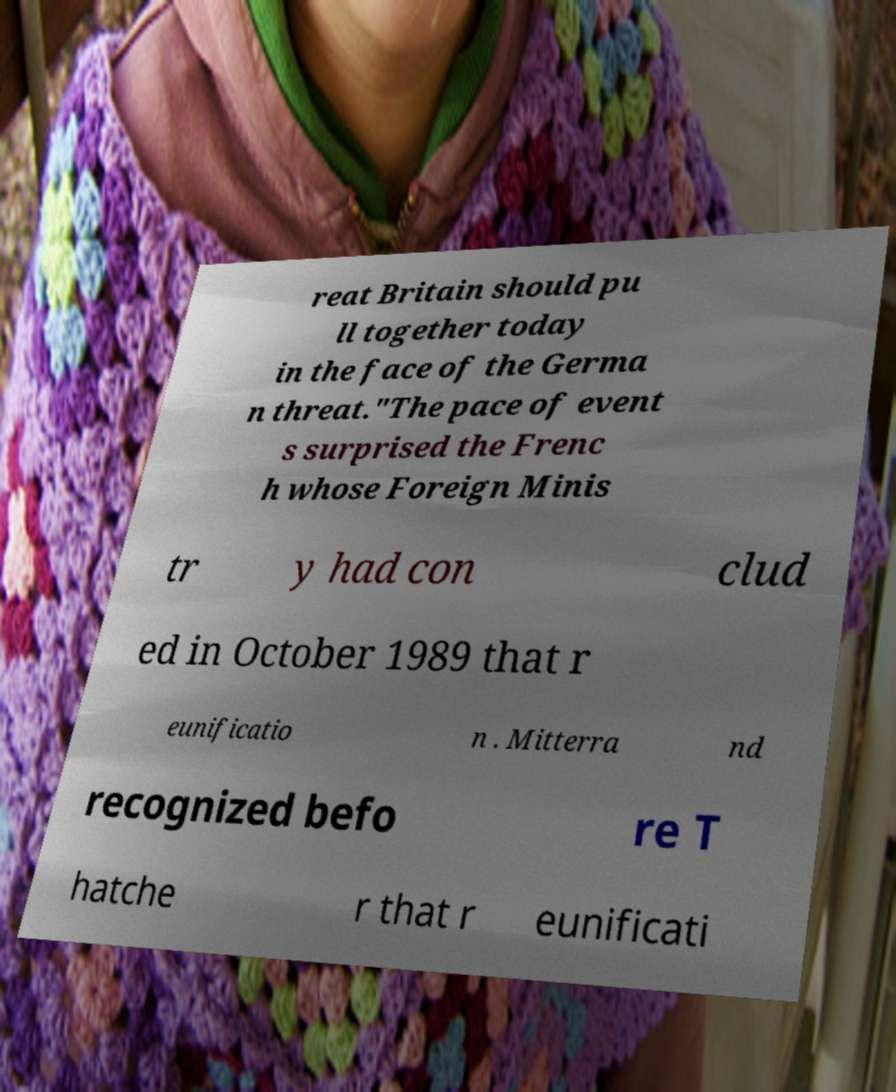I need the written content from this picture converted into text. Can you do that? reat Britain should pu ll together today in the face of the Germa n threat."The pace of event s surprised the Frenc h whose Foreign Minis tr y had con clud ed in October 1989 that r eunificatio n . Mitterra nd recognized befo re T hatche r that r eunificati 